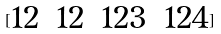Convert formula to latex. <formula><loc_0><loc_0><loc_500><loc_500>[ \begin{matrix} 1 2 & 1 2 & 1 2 3 & 1 2 4 \\ \end{matrix} ]</formula> 